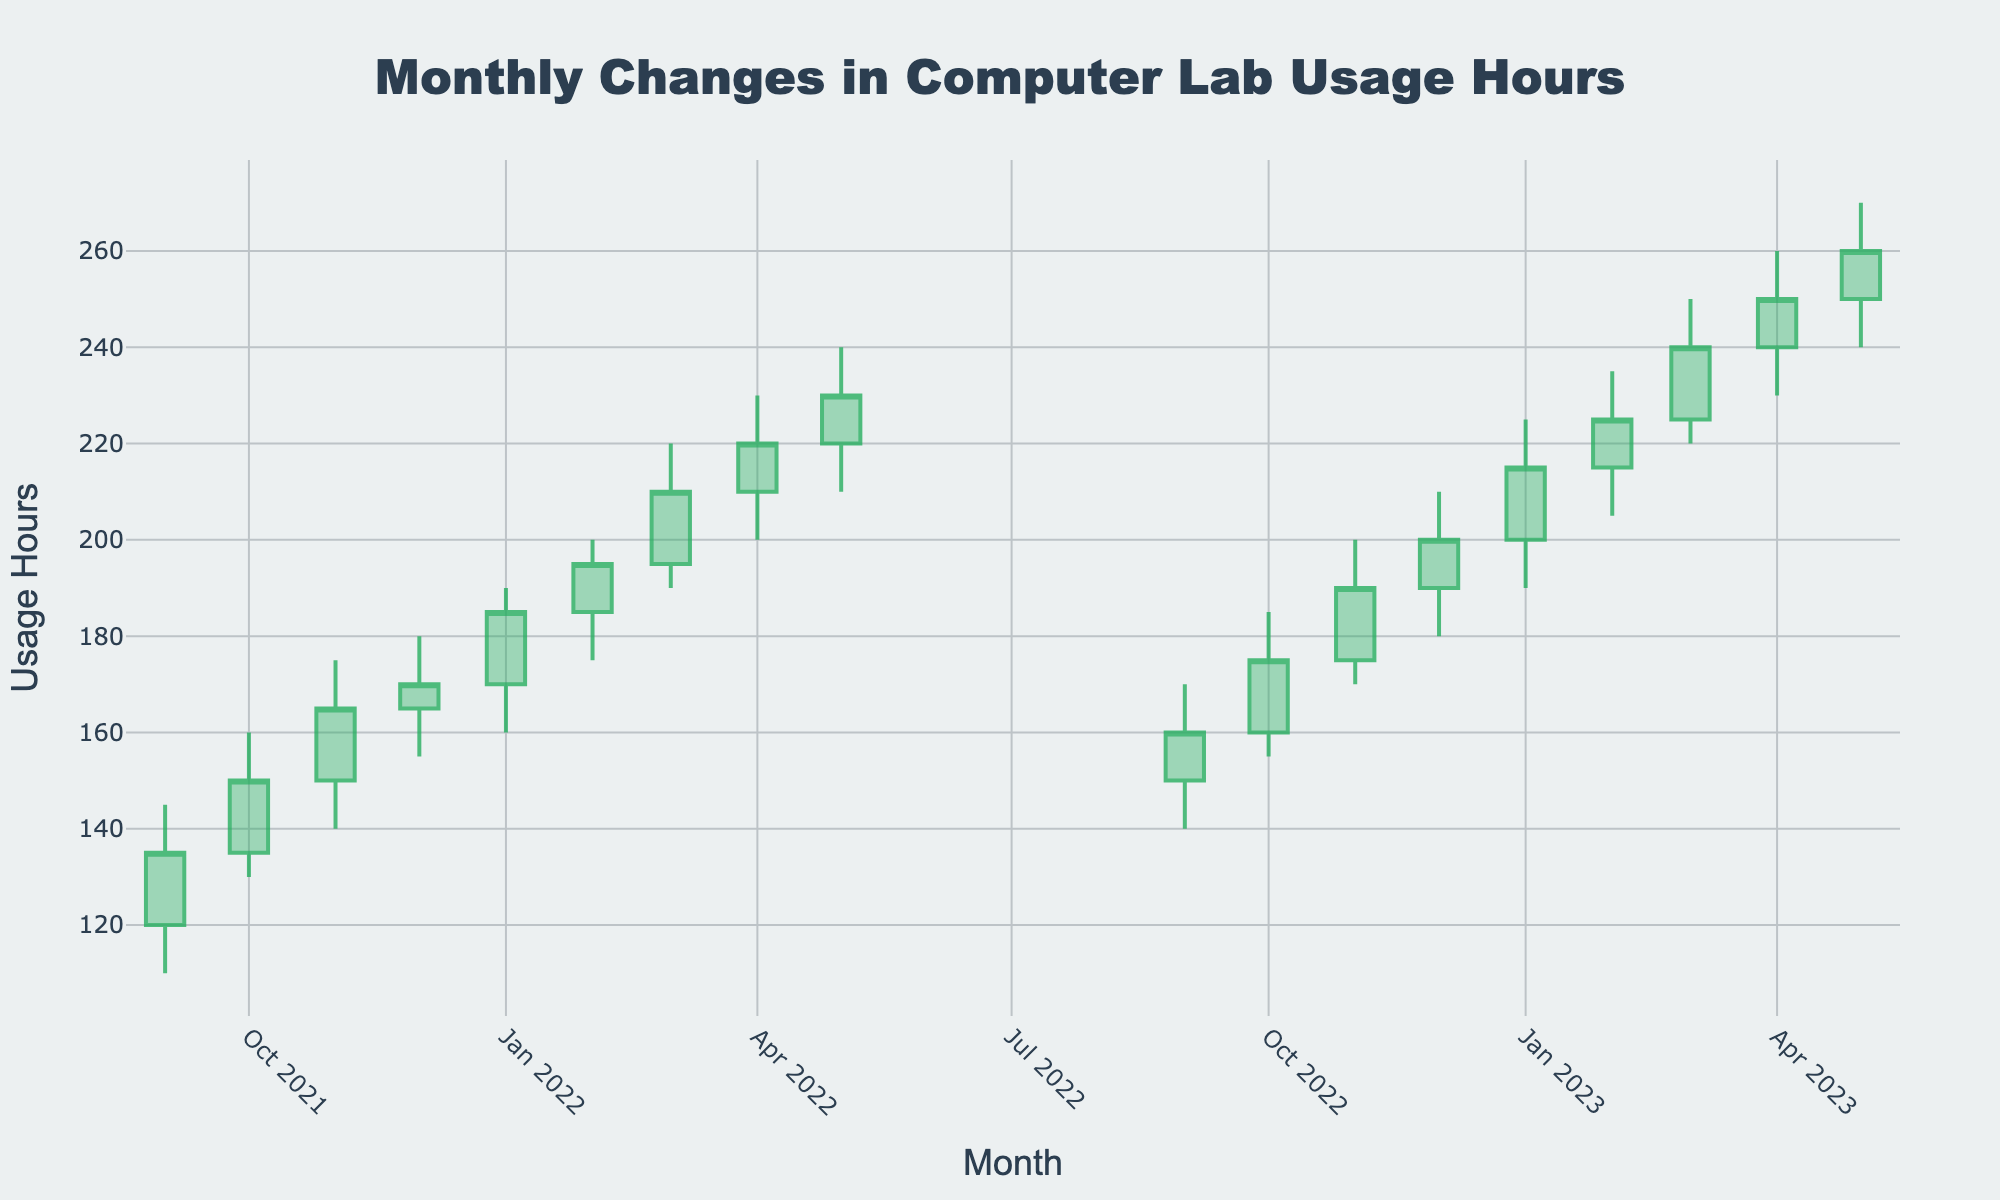what is the title of the figure? The title is located at the top of the figure; it's often the most prominent text.
Answer: Monthly Changes in Computer Lab Usage Hours What months does the data cover? By looking at the x-axis, we can see labels indicating the start and end months of the data. They range from Sep 2021 to May 2023.
Answer: Sep 2021 to May 2023 Which month had the highest peak usage? By comparing the highest points of each candlestick, you can determine the month with the highest high value. The peak value of 270 hours is seen in May 2023.
Answer: May 2023 What was the usage trend between Nov 2021 and Mar 2022? By examining the trend in the candlestick patterns from Nov 2021 (150 open) to Mar 2022 (210 close), we can observe the usage generally increased over this period.
Answer: Increasing How does the usage in Jan 2022 compare to Jan 2023? Compare the open, high, low, and close values of Jan 2022 (170, 190, 160, 185) and Jan 2023 (200, 225, 190, 215). All values are higher in Jan 2023 than in Jan 2022.
Answer: Higher in Jan 2023 What is the average closing value for the academic year 2022-2023 (Sep 2022 to May 2023)? Sum of closing values from Sep 2022 (160) to May 2023 (260) and divide by the number of months (9). Average = (160 + 175 + 190 + 200 + 215 + 225 + 240 + 250 + 260) / 9 = 1245 / 9 = 138.33
Answer: 138.33 Which month between Sep 2021 and May 2022 had the largest increase in usage? Identify the month with the largest difference between the close and open values. From Sep 2021 to May 2022, the largest increase is in May 2022 (230 - 220 = 10).
Answer: May 2022 How many months had a closing value higher than 220 hours? Count the number of months where the closing (close) value exceeds 220. They are found in Mar 2022 (210), Apr 2022 (220), May 2022 (230), Mar 2023 (240), Apr 2023 (250), and May 2023 (260).
Answer: 3 months 